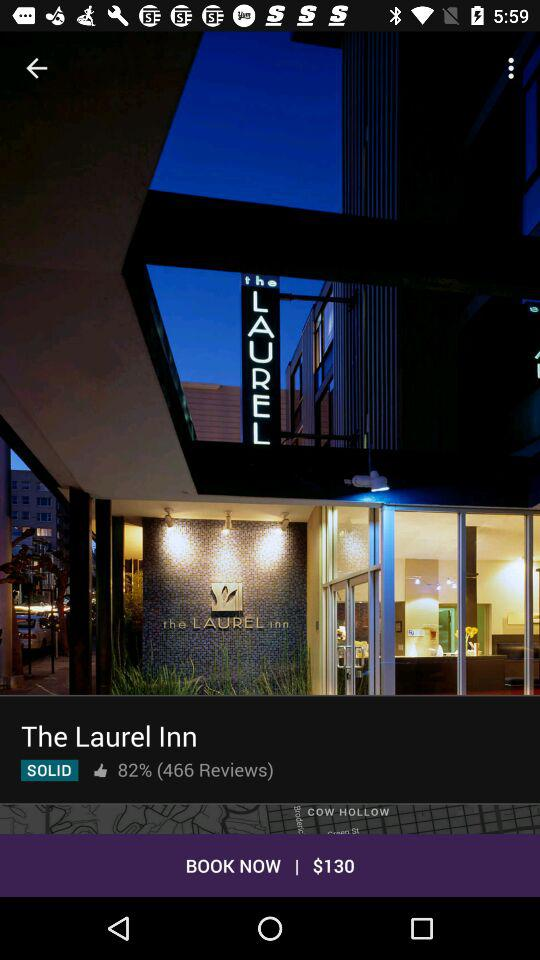What is the booking amount? The booking amount is $130. 